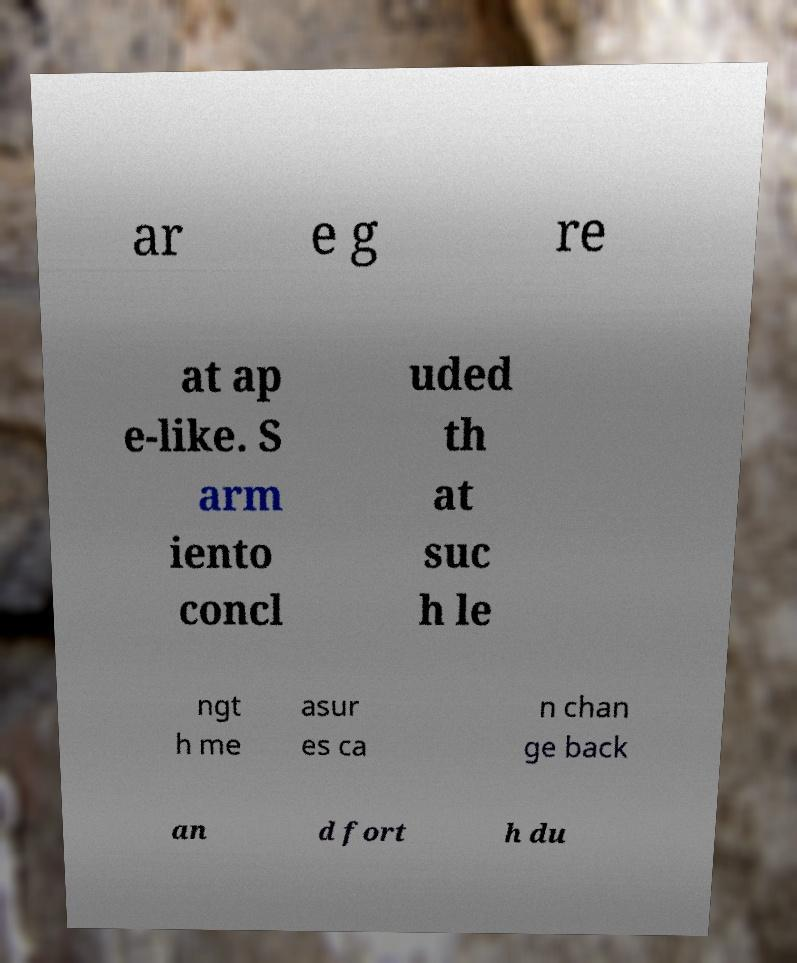Can you accurately transcribe the text from the provided image for me? ar e g re at ap e-like. S arm iento concl uded th at suc h le ngt h me asur es ca n chan ge back an d fort h du 